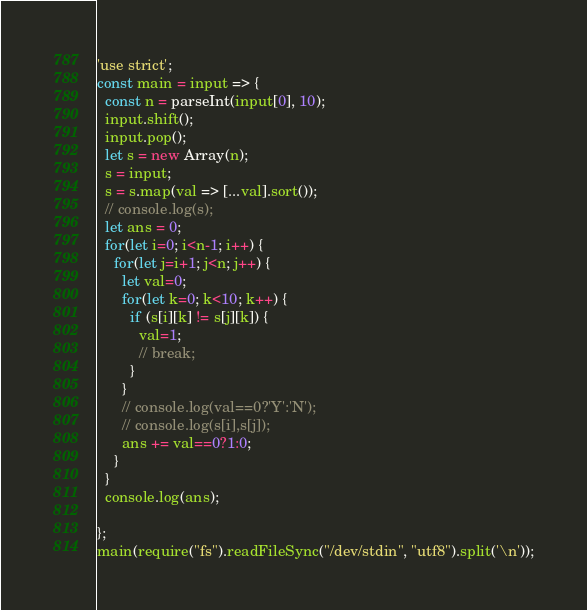Convert code to text. <code><loc_0><loc_0><loc_500><loc_500><_JavaScript_>'use strict';
const main = input => {
  const n = parseInt(input[0], 10);
  input.shift();
  input.pop();
  let s = new Array(n);
  s = input;
  s = s.map(val => [...val].sort());
  // console.log(s);
  let ans = 0;
  for(let i=0; i<n-1; i++) {
    for(let j=i+1; j<n; j++) {
      let val=0;
      for(let k=0; k<10; k++) {
        if (s[i][k] != s[j][k]) {
          val=1;
          // break;
        }
      }
      // console.log(val==0?'Y':'N');
      // console.log(s[i],s[j]);
      ans += val==0?1:0;
    }
  }
  console.log(ans);
  
};
main(require("fs").readFileSync("/dev/stdin", "utf8").split('\n'));</code> 